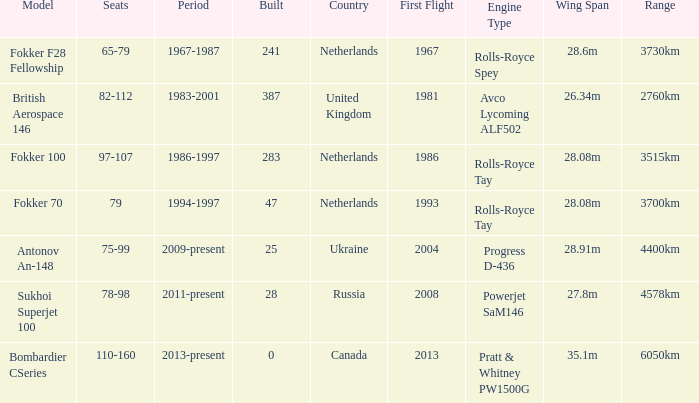Between which years were there 241 fokker 70 model cabins built? 1994-1997. 